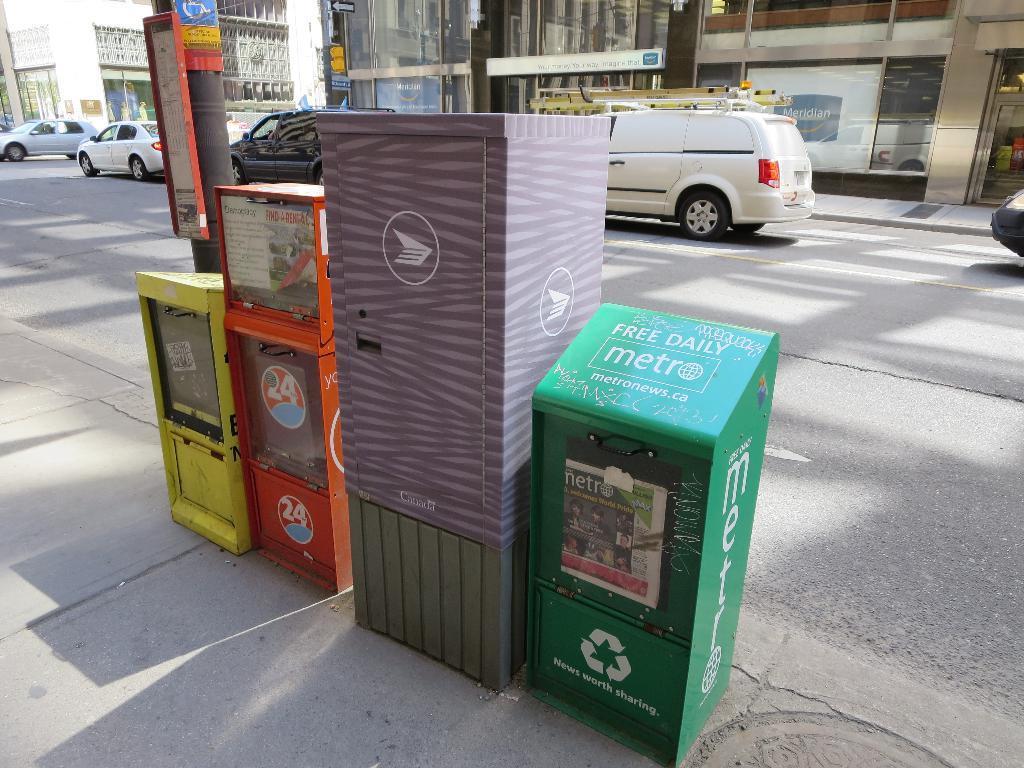In one or two sentences, can you explain what this image depicts? In this picture I can see few bins in the middle, in the background there are vehicles and buildings. 